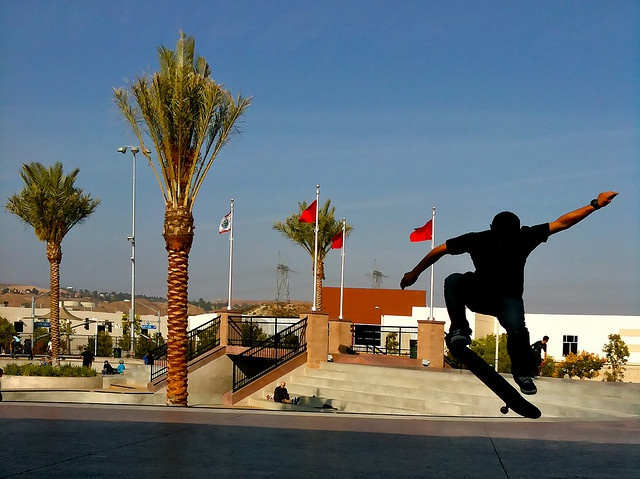Describe the objects in this image and their specific colors. I can see people in teal, black, maroon, brown, and darkgray tones, skateboard in teal, black, beige, darkgray, and gray tones, people in teal, black, maroon, red, and gray tones, people in teal, black, brown, tan, and maroon tones, and people in teal, black, maroon, and gray tones in this image. 